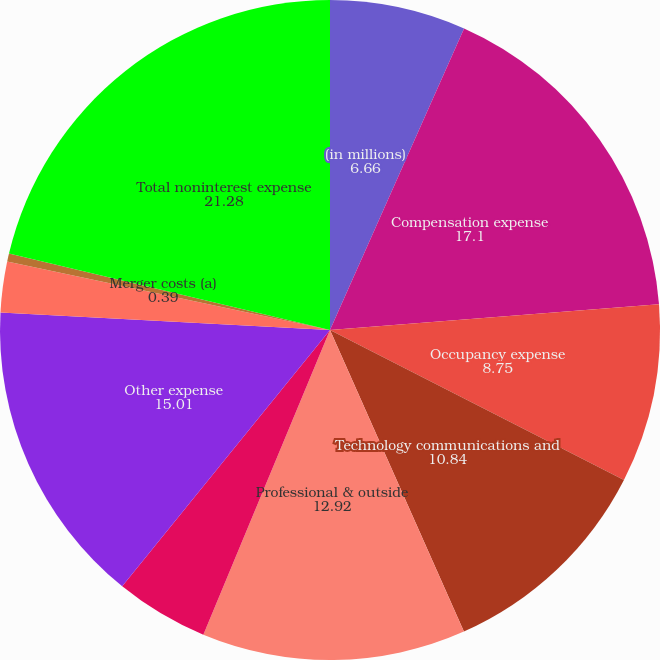Convert chart. <chart><loc_0><loc_0><loc_500><loc_500><pie_chart><fcel>(in millions)<fcel>Compensation expense<fcel>Occupancy expense<fcel>Technology communications and<fcel>Professional & outside<fcel>Marketing<fcel>Other expense<fcel>Amortization of intangibles<fcel>Merger costs (a)<fcel>Total noninterest expense<nl><fcel>6.66%<fcel>17.1%<fcel>8.75%<fcel>10.84%<fcel>12.92%<fcel>4.57%<fcel>15.01%<fcel>2.48%<fcel>0.39%<fcel>21.28%<nl></chart> 